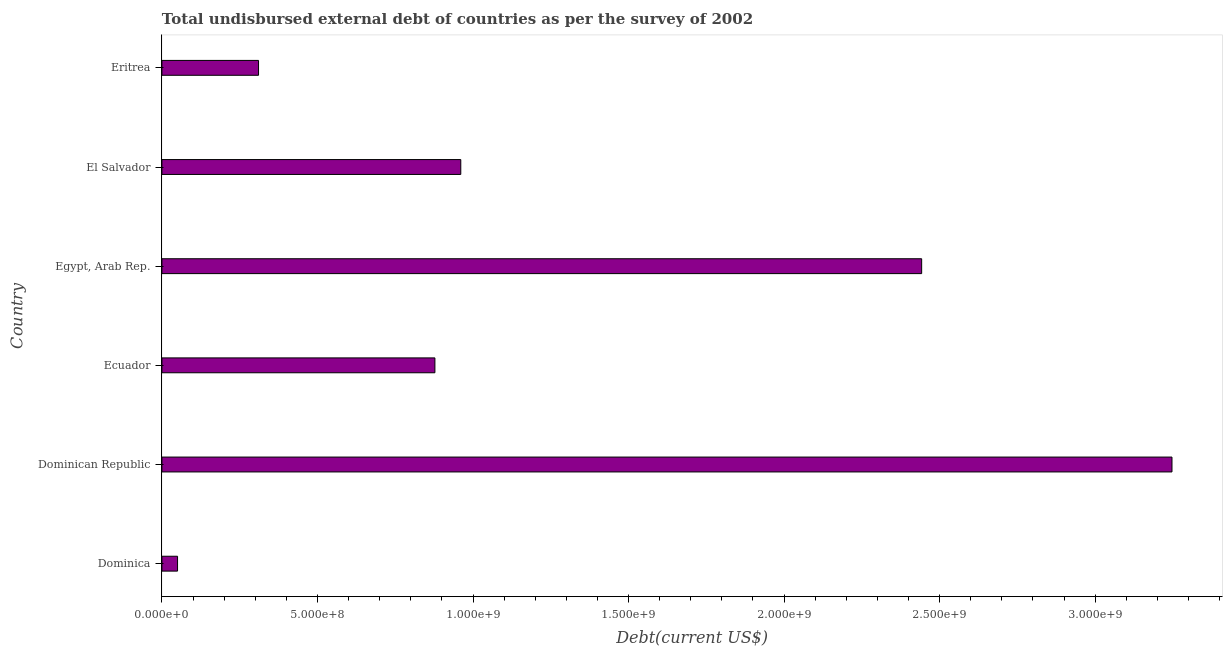Does the graph contain grids?
Your answer should be compact. No. What is the title of the graph?
Offer a terse response. Total undisbursed external debt of countries as per the survey of 2002. What is the label or title of the X-axis?
Offer a very short reply. Debt(current US$). What is the total debt in Egypt, Arab Rep.?
Ensure brevity in your answer.  2.44e+09. Across all countries, what is the maximum total debt?
Offer a very short reply. 3.25e+09. Across all countries, what is the minimum total debt?
Give a very brief answer. 5.03e+07. In which country was the total debt maximum?
Keep it short and to the point. Dominican Republic. In which country was the total debt minimum?
Offer a terse response. Dominica. What is the sum of the total debt?
Ensure brevity in your answer.  7.89e+09. What is the difference between the total debt in Ecuador and Egypt, Arab Rep.?
Your response must be concise. -1.56e+09. What is the average total debt per country?
Provide a short and direct response. 1.31e+09. What is the median total debt?
Your response must be concise. 9.19e+08. What is the ratio of the total debt in El Salvador to that in Eritrea?
Provide a succinct answer. 3.09. Is the total debt in Dominica less than that in Ecuador?
Offer a terse response. Yes. What is the difference between the highest and the second highest total debt?
Provide a short and direct response. 8.05e+08. Is the sum of the total debt in Dominican Republic and Ecuador greater than the maximum total debt across all countries?
Provide a succinct answer. Yes. What is the difference between the highest and the lowest total debt?
Your answer should be very brief. 3.20e+09. In how many countries, is the total debt greater than the average total debt taken over all countries?
Your answer should be compact. 2. How many bars are there?
Keep it short and to the point. 6. How many countries are there in the graph?
Your response must be concise. 6. What is the Debt(current US$) in Dominica?
Provide a succinct answer. 5.03e+07. What is the Debt(current US$) in Dominican Republic?
Provide a short and direct response. 3.25e+09. What is the Debt(current US$) in Ecuador?
Keep it short and to the point. 8.78e+08. What is the Debt(current US$) of Egypt, Arab Rep.?
Your answer should be compact. 2.44e+09. What is the Debt(current US$) in El Salvador?
Make the answer very short. 9.61e+08. What is the Debt(current US$) in Eritrea?
Your answer should be compact. 3.11e+08. What is the difference between the Debt(current US$) in Dominica and Dominican Republic?
Keep it short and to the point. -3.20e+09. What is the difference between the Debt(current US$) in Dominica and Ecuador?
Provide a succinct answer. -8.27e+08. What is the difference between the Debt(current US$) in Dominica and Egypt, Arab Rep.?
Provide a short and direct response. -2.39e+09. What is the difference between the Debt(current US$) in Dominica and El Salvador?
Give a very brief answer. -9.10e+08. What is the difference between the Debt(current US$) in Dominica and Eritrea?
Offer a very short reply. -2.60e+08. What is the difference between the Debt(current US$) in Dominican Republic and Ecuador?
Offer a very short reply. 2.37e+09. What is the difference between the Debt(current US$) in Dominican Republic and Egypt, Arab Rep.?
Offer a terse response. 8.05e+08. What is the difference between the Debt(current US$) in Dominican Republic and El Salvador?
Provide a short and direct response. 2.29e+09. What is the difference between the Debt(current US$) in Dominican Republic and Eritrea?
Offer a very short reply. 2.94e+09. What is the difference between the Debt(current US$) in Ecuador and Egypt, Arab Rep.?
Your response must be concise. -1.56e+09. What is the difference between the Debt(current US$) in Ecuador and El Salvador?
Offer a very short reply. -8.32e+07. What is the difference between the Debt(current US$) in Ecuador and Eritrea?
Offer a very short reply. 5.67e+08. What is the difference between the Debt(current US$) in Egypt, Arab Rep. and El Salvador?
Keep it short and to the point. 1.48e+09. What is the difference between the Debt(current US$) in Egypt, Arab Rep. and Eritrea?
Your answer should be compact. 2.13e+09. What is the difference between the Debt(current US$) in El Salvador and Eritrea?
Make the answer very short. 6.50e+08. What is the ratio of the Debt(current US$) in Dominica to that in Dominican Republic?
Offer a very short reply. 0.01. What is the ratio of the Debt(current US$) in Dominica to that in Ecuador?
Give a very brief answer. 0.06. What is the ratio of the Debt(current US$) in Dominica to that in Egypt, Arab Rep.?
Give a very brief answer. 0.02. What is the ratio of the Debt(current US$) in Dominica to that in El Salvador?
Your answer should be compact. 0.05. What is the ratio of the Debt(current US$) in Dominica to that in Eritrea?
Give a very brief answer. 0.16. What is the ratio of the Debt(current US$) in Dominican Republic to that in Egypt, Arab Rep.?
Offer a terse response. 1.33. What is the ratio of the Debt(current US$) in Dominican Republic to that in El Salvador?
Offer a terse response. 3.38. What is the ratio of the Debt(current US$) in Dominican Republic to that in Eritrea?
Make the answer very short. 10.45. What is the ratio of the Debt(current US$) in Ecuador to that in Egypt, Arab Rep.?
Ensure brevity in your answer.  0.36. What is the ratio of the Debt(current US$) in Ecuador to that in Eritrea?
Provide a short and direct response. 2.83. What is the ratio of the Debt(current US$) in Egypt, Arab Rep. to that in El Salvador?
Offer a very short reply. 2.54. What is the ratio of the Debt(current US$) in Egypt, Arab Rep. to that in Eritrea?
Keep it short and to the point. 7.86. What is the ratio of the Debt(current US$) in El Salvador to that in Eritrea?
Provide a succinct answer. 3.09. 